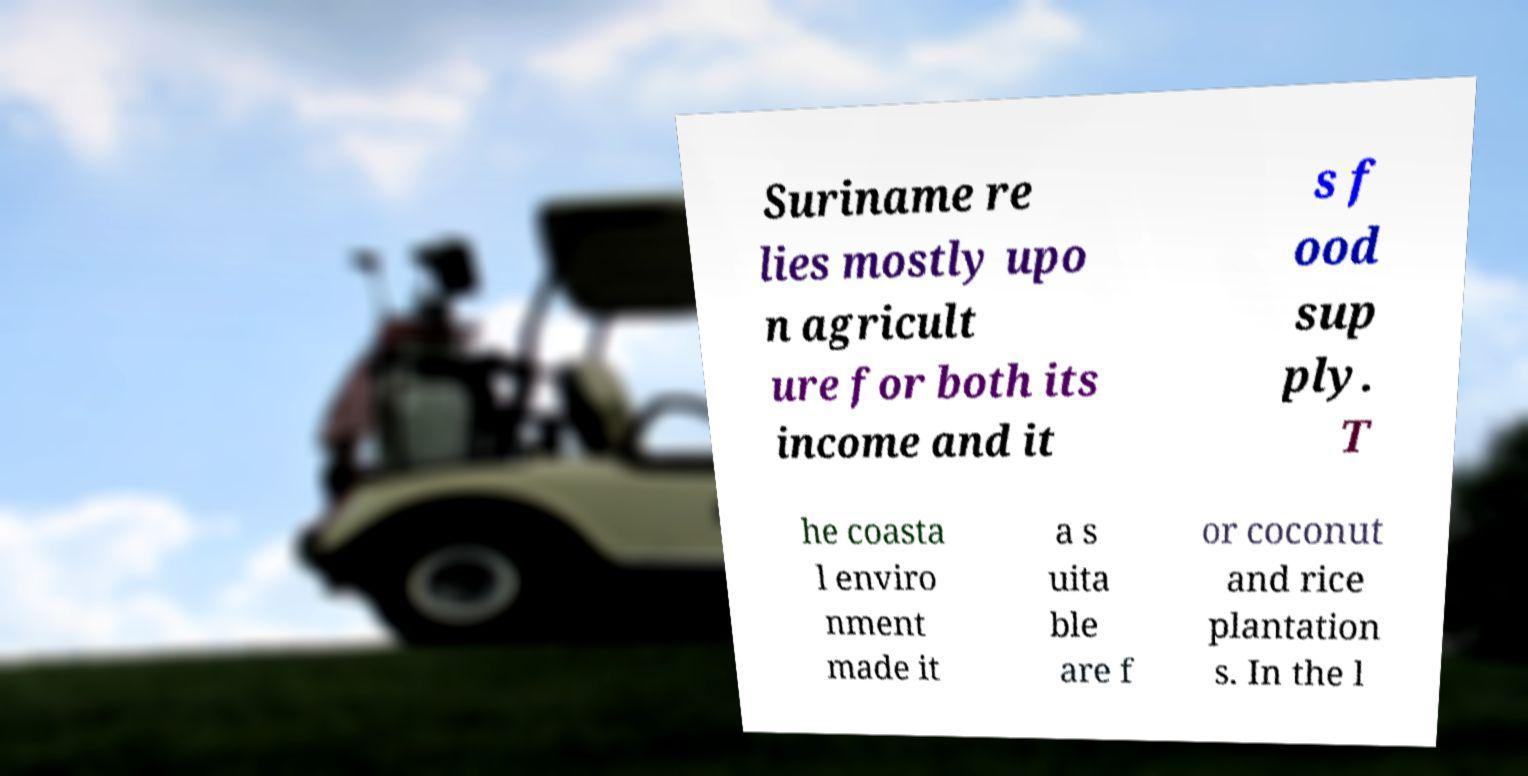Can you accurately transcribe the text from the provided image for me? Suriname re lies mostly upo n agricult ure for both its income and it s f ood sup ply. T he coasta l enviro nment made it a s uita ble are f or coconut and rice plantation s. In the l 